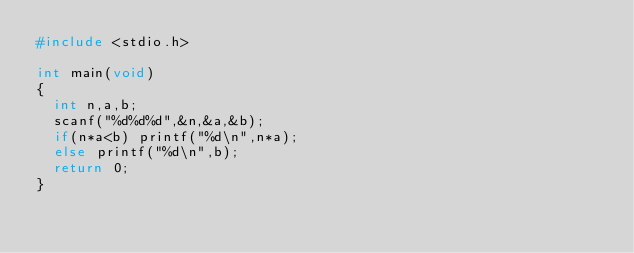Convert code to text. <code><loc_0><loc_0><loc_500><loc_500><_C_>#include <stdio.h>

int main(void)
{
	int n,a,b;
	scanf("%d%d%d",&n,&a,&b);
	if(n*a<b) printf("%d\n",n*a);
	else printf("%d\n",b);
	return 0;
}

</code> 